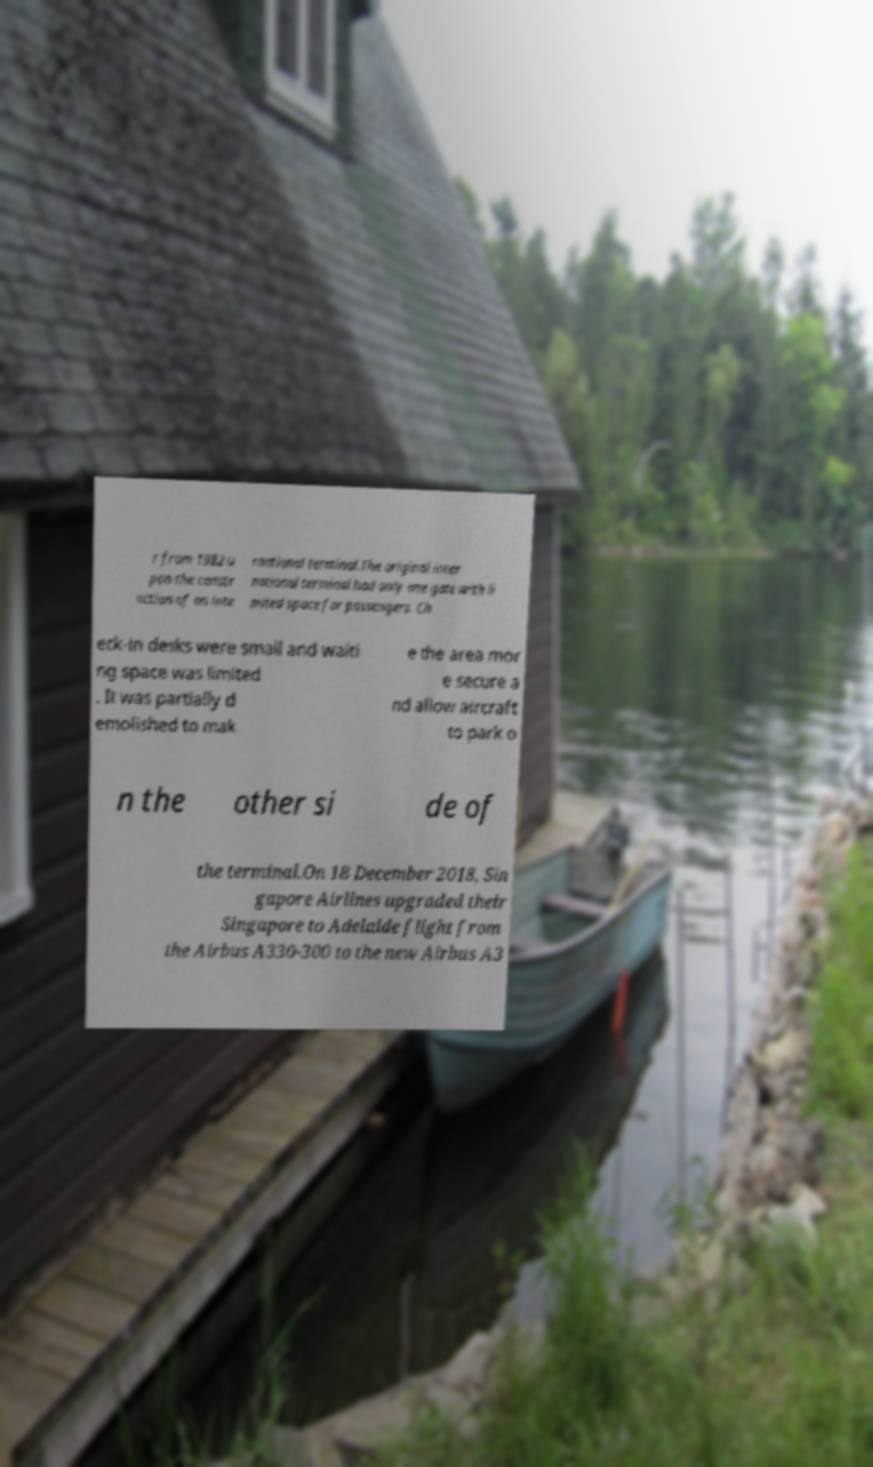Can you accurately transcribe the text from the provided image for me? r from 1982 u pon the constr uction of an inte rnational terminal.The original inter national terminal had only one gate with li mited space for passengers. Ch eck-in desks were small and waiti ng space was limited . It was partially d emolished to mak e the area mor e secure a nd allow aircraft to park o n the other si de of the terminal.On 18 December 2018, Sin gapore Airlines upgraded their Singapore to Adelaide flight from the Airbus A330-300 to the new Airbus A3 